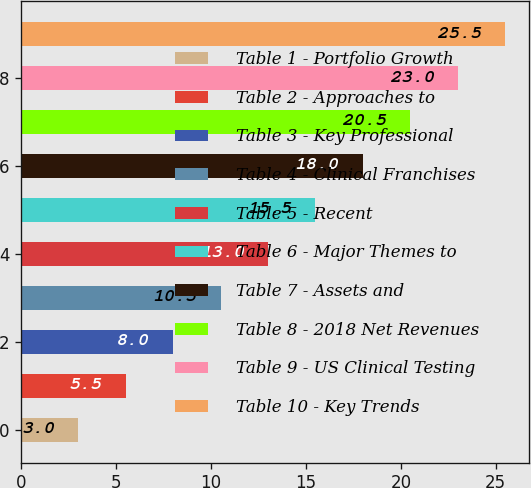<chart> <loc_0><loc_0><loc_500><loc_500><bar_chart><fcel>Table 1 - Portfolio Growth<fcel>Table 2 - Approaches to<fcel>Table 3 - Key Professional<fcel>Table 4 - Clinical Franchises<fcel>Table 5 - Recent<fcel>Table 6 - Major Themes to<fcel>Table 7 - Assets and<fcel>Table 8 - 2018 Net Revenues<fcel>Table 9 - US Clinical Testing<fcel>Table 10 - Key Trends<nl><fcel>3<fcel>5.5<fcel>8<fcel>10.5<fcel>13<fcel>15.5<fcel>18<fcel>20.5<fcel>23<fcel>25.5<nl></chart> 